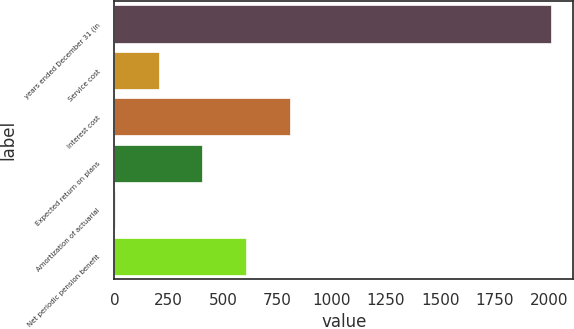<chart> <loc_0><loc_0><loc_500><loc_500><bar_chart><fcel>years ended December 31 (in<fcel>Service cost<fcel>Interest cost<fcel>Expected return on plans<fcel>Amortization of actuarial<fcel>Net periodic pension benefit<nl><fcel>2011<fcel>202.9<fcel>805.6<fcel>403.8<fcel>2<fcel>604.7<nl></chart> 